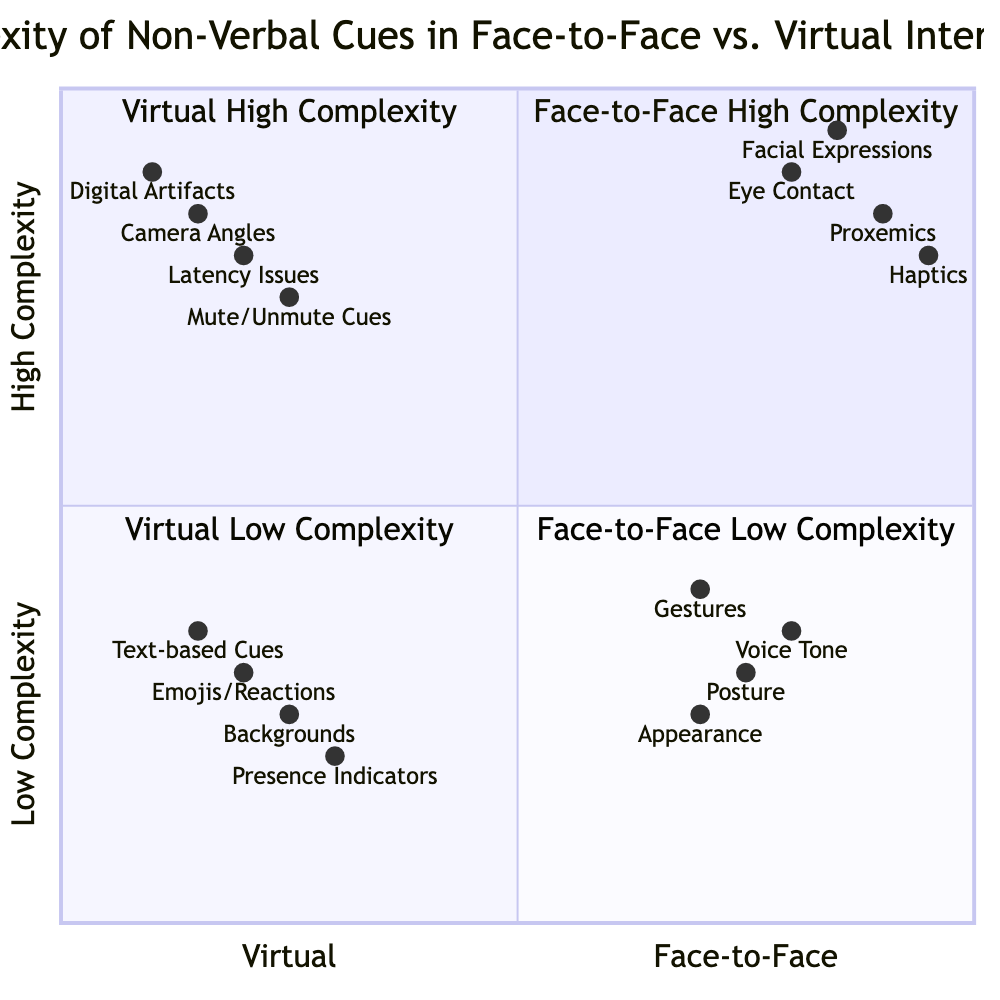What are the non-verbal cues that fall under Face-to-Face High Complexity? The quadrant labeled 'Face-to-Face High Complexity' contains Eye Contact, Facial Expressions, Proxemics, and Haptics.
Answer: Eye Contact, Facial Expressions, Proxemics, Haptics Which non-verbal cue is most complex in the Face-to-Face interactions? In the 'Face-to-Face High Complexity' quadrant, Haptics has the highest y-axis value of 0.95, making it the most complex cue.
Answer: Haptics What is the lowest complexity non-verbal cue in Virtual interactions? In the 'Virtual Low Complexity' quadrant, Presence Indicators has the highest y-axis value of 0.3, making it the least complex cue.
Answer: Presence Indicators How many non-verbal cues are categorized under Virtual High Complexity? There are four cues listed in the 'Virtual High Complexity' quadrant: Latency Issues, Camera Angles, Digital Artifacts, and Mute/Unmute Cues.
Answer: Four Which quadrant contains the most non-verbal cues? The 'Face-to-Face High Complexity' quadrant has four cues, which is the same as the 'Virtual High Complexity' quadrant; however, 'Face-to-Face Low Complexity' also has four, so there are equal counts in these quadrants.
Answer: Equal counts What is the y-axis value for Digital Artifacts? The 'Digital Artifacts' non-verbal cue is located in the 'Virtual High Complexity' quadrant and has a y-axis value of 0.9.
Answer: 0.9 Which non-verbal cue has the lowest value in both axes? The 'Text-based Cues' is in the 'Virtual Low Complexity' quadrant with an x-axis value of 0.15 and a y-axis value of 0.35, making it the lowest value in both axes.
Answer: Text-based Cues What can be inferred about the complexity of Emojis/Reactions in Virtual interactions? The 'Emojis/Reactions' cue, located in the 'Virtual Low Complexity' quadrant, has a y-axis value of 0.3 which indicates a lower complexity compared to the cues in the 'Face-to-Face High Complexity' quadrant.
Answer: Lower complexity What is the relationship between Camera Angles and Facial Expressions regarding their complexity? Camera Angles has a higher x-axis value of 0.15 compared to Facial Expressions which is 0.85, indicating that its complexity is lower in a virtual setting than the Facial Expressions in face-to-face interactions.
Answer: Lower complexity in virtual interactions 